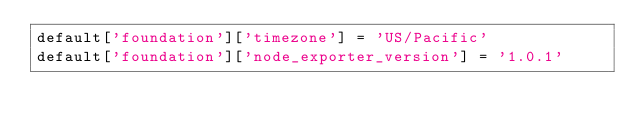<code> <loc_0><loc_0><loc_500><loc_500><_Ruby_>default['foundation']['timezone'] = 'US/Pacific'
default['foundation']['node_exporter_version'] = '1.0.1'
</code> 